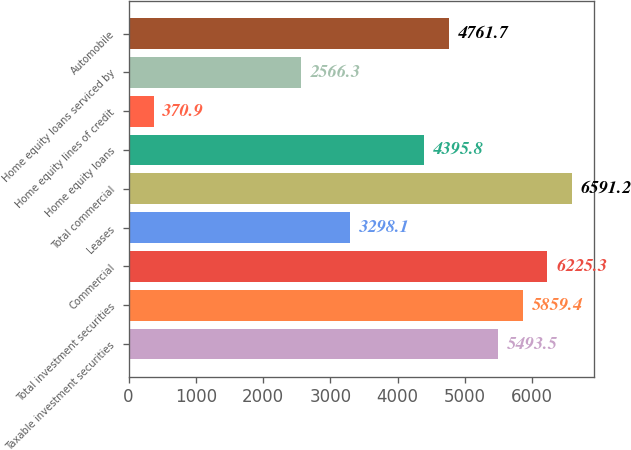<chart> <loc_0><loc_0><loc_500><loc_500><bar_chart><fcel>Taxable investment securities<fcel>Total investment securities<fcel>Commercial<fcel>Leases<fcel>Total commercial<fcel>Home equity loans<fcel>Home equity lines of credit<fcel>Home equity loans serviced by<fcel>Automobile<nl><fcel>5493.5<fcel>5859.4<fcel>6225.3<fcel>3298.1<fcel>6591.2<fcel>4395.8<fcel>370.9<fcel>2566.3<fcel>4761.7<nl></chart> 